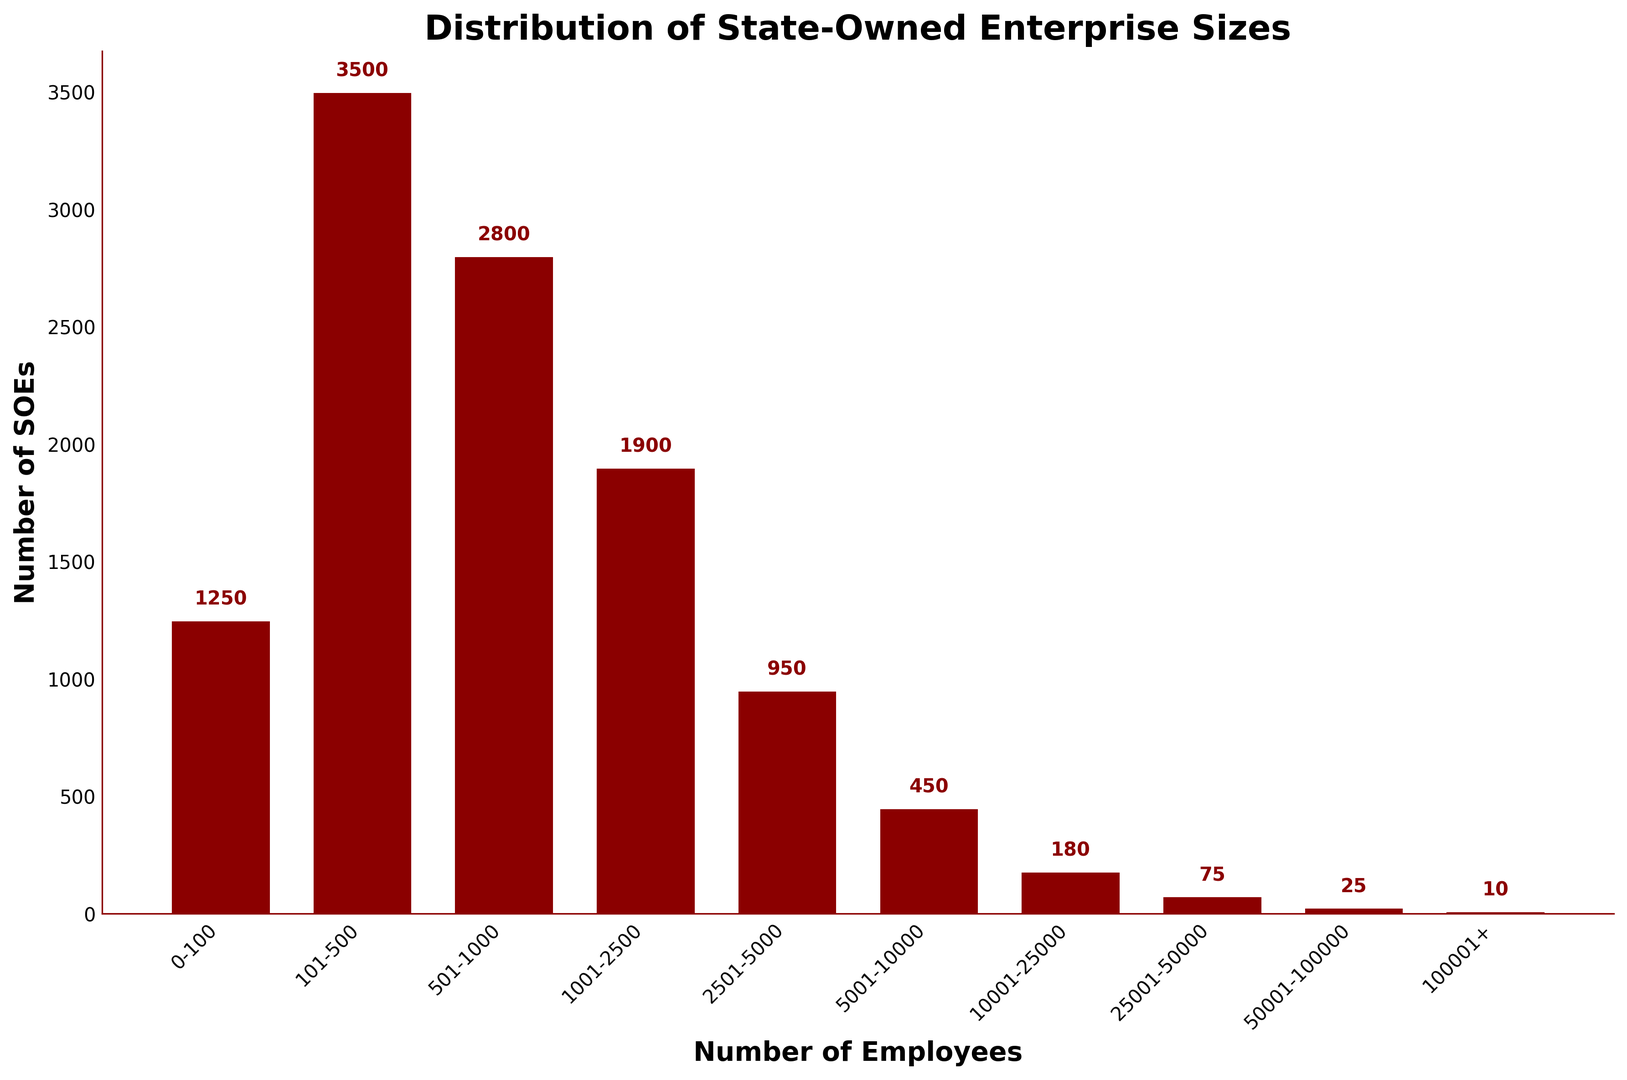What is the total number of state-owned enterprises with 1001 or more employees? Sum the number of SOEs for the following groups: 1001-2500, 2501-5000, 5001-10000, 10001-25000, 25001-50000, 50001-100000, and 100001+. So, \(1900 + 950 + 450 + 180 + 75 + 25 + 10 = 3590\).
Answer: 3590 Which group has the highest number of state-owned enterprises? By looking at the heights of the bars, the group '101-500' has the tallest bar, indicating the highest number of SOEs.
Answer: 101-500 What is the average number of SOEs in the groups with fewer than 500 employees? Sum the number of SOEs for the groups 0-100 and 101-500, then divide by 2. So, \((1250 + 3500)/2 = 4750/2 = 2375\).
Answer: 2375 How many more state-owned enterprises are in the 101-500 group compared to the 1001-2500 group? Subtract the number of SOEs in the 1001-2500 group from the number in the 101-500 group. So, \(3500 - 1900 = 1600\).
Answer: 1600 Which group has the smallest number of state-owned enterprises, and how many does it have? The group '100001+' has the shortest bar, indicating the smallest number of SOEs, which is 10.
Answer: 100001+, 10 What is the combined number of state-owned enterprises in the 0-100 and 501-1000 groups? Add the number of SOEs in the 0-100 group and the 501-1000 group. So, \(1250 + 2800 = 4050\).
Answer: 4050 Is there a visual pattern in the distribution of state-owned enterprise sizes? The bars decrease in height as the number of employees increases, indicating there are more smaller SOEs and fewer larger SOEs.
Answer: Decrease in height How many times more state-owned enterprises are there in the 101-500 group compared to the 100001+ group? Divide the number of SOEs in the 101-500 group by the number in the 100001+ group. So, \(3500 / 10 = 350\).
Answer: 350 What is the difference in the number of state-owned enterprises between the groups with the largest and smallest counts? Subtract the number of SOEs in the 100001+ group from the number in the 101-500 group. So, \(3500 - 10 = 3490\).
Answer: 3490 How many state-owned enterprises have between 10001 and 100000 employees? Sum the number of SOEs for the groups 10001-25000, 25001-50000, and 50001-100000. So, \(180 + 75 + 25 = 280\).
Answer: 280 